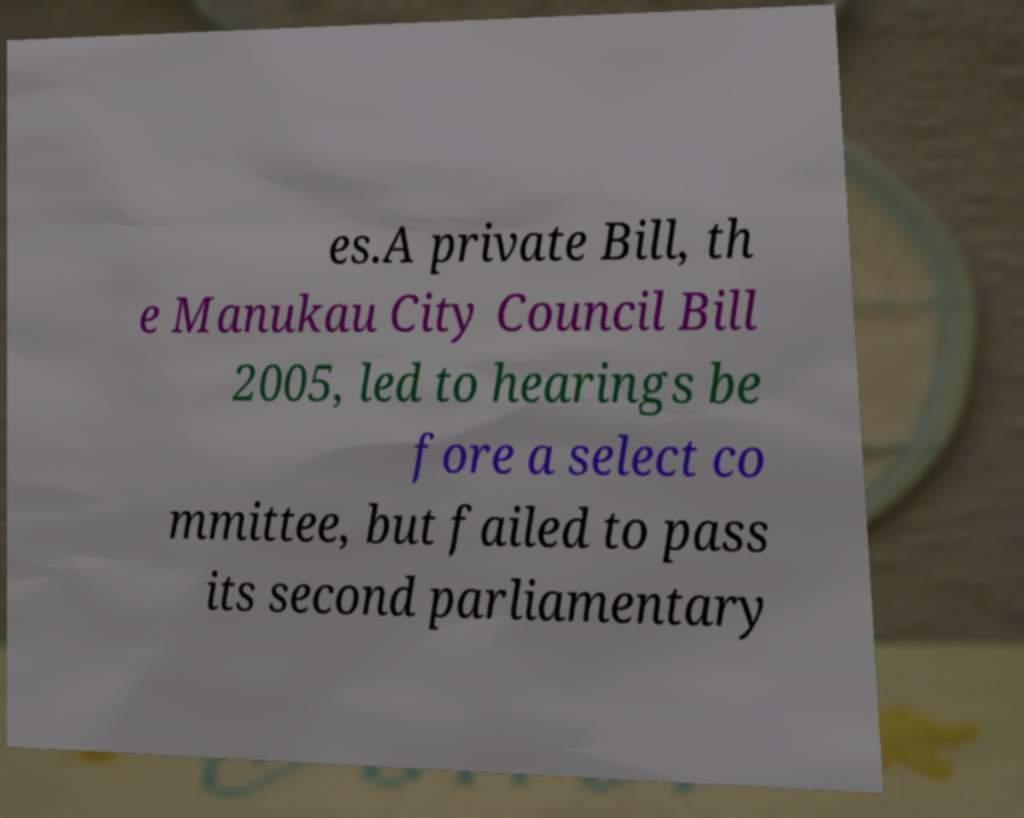Could you extract and type out the text from this image? es.A private Bill, th e Manukau City Council Bill 2005, led to hearings be fore a select co mmittee, but failed to pass its second parliamentary 